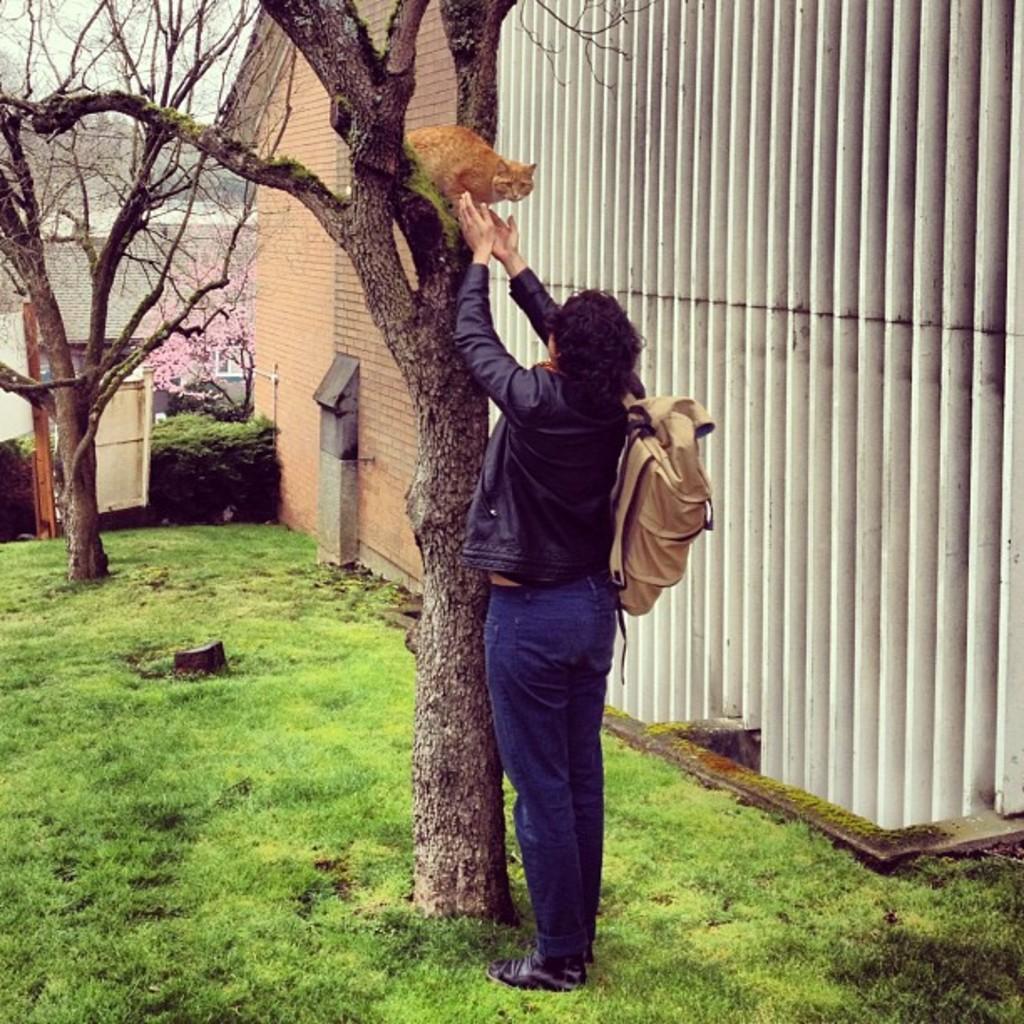How would you summarize this image in a sentence or two? In this picture we can observe a cat which is in cream color on the tree. In front of the tree there is a woman standing, holding a bag on her shoulders. We can observe some grass on the land. In the right side there is a building. In the background we can observe a sky here. 